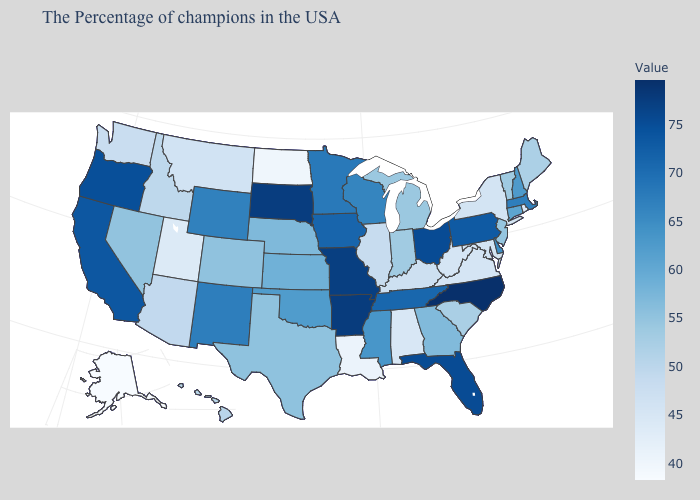Which states hav the highest value in the West?
Short answer required. Oregon. Which states have the lowest value in the USA?
Give a very brief answer. Alaska. Which states have the lowest value in the West?
Give a very brief answer. Alaska. Among the states that border West Virginia , which have the highest value?
Be succinct. Ohio. Is the legend a continuous bar?
Answer briefly. Yes. Does New Hampshire have a higher value than New Jersey?
Be succinct. Yes. Which states hav the highest value in the South?
Keep it brief. North Carolina. Does Montana have the lowest value in the West?
Concise answer only. No. 